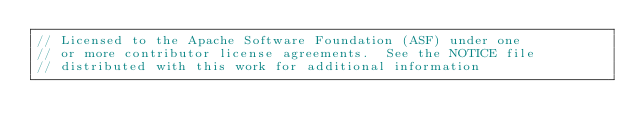<code> <loc_0><loc_0><loc_500><loc_500><_Cuda_>// Licensed to the Apache Software Foundation (ASF) under one
// or more contributor license agreements.  See the NOTICE file
// distributed with this work for additional information</code> 